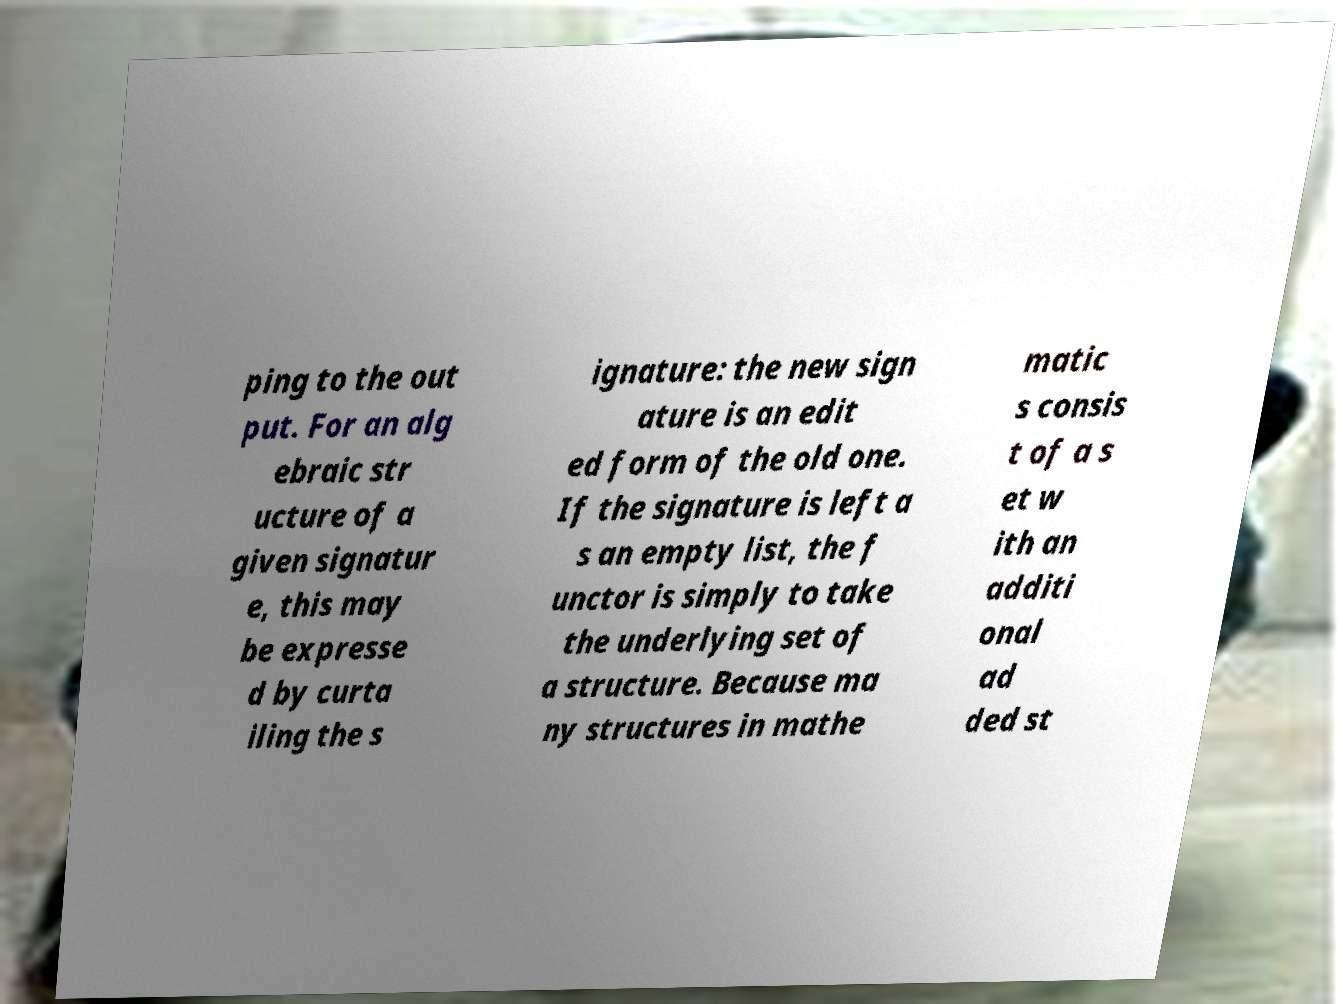Could you assist in decoding the text presented in this image and type it out clearly? ping to the out put. For an alg ebraic str ucture of a given signatur e, this may be expresse d by curta iling the s ignature: the new sign ature is an edit ed form of the old one. If the signature is left a s an empty list, the f unctor is simply to take the underlying set of a structure. Because ma ny structures in mathe matic s consis t of a s et w ith an additi onal ad ded st 